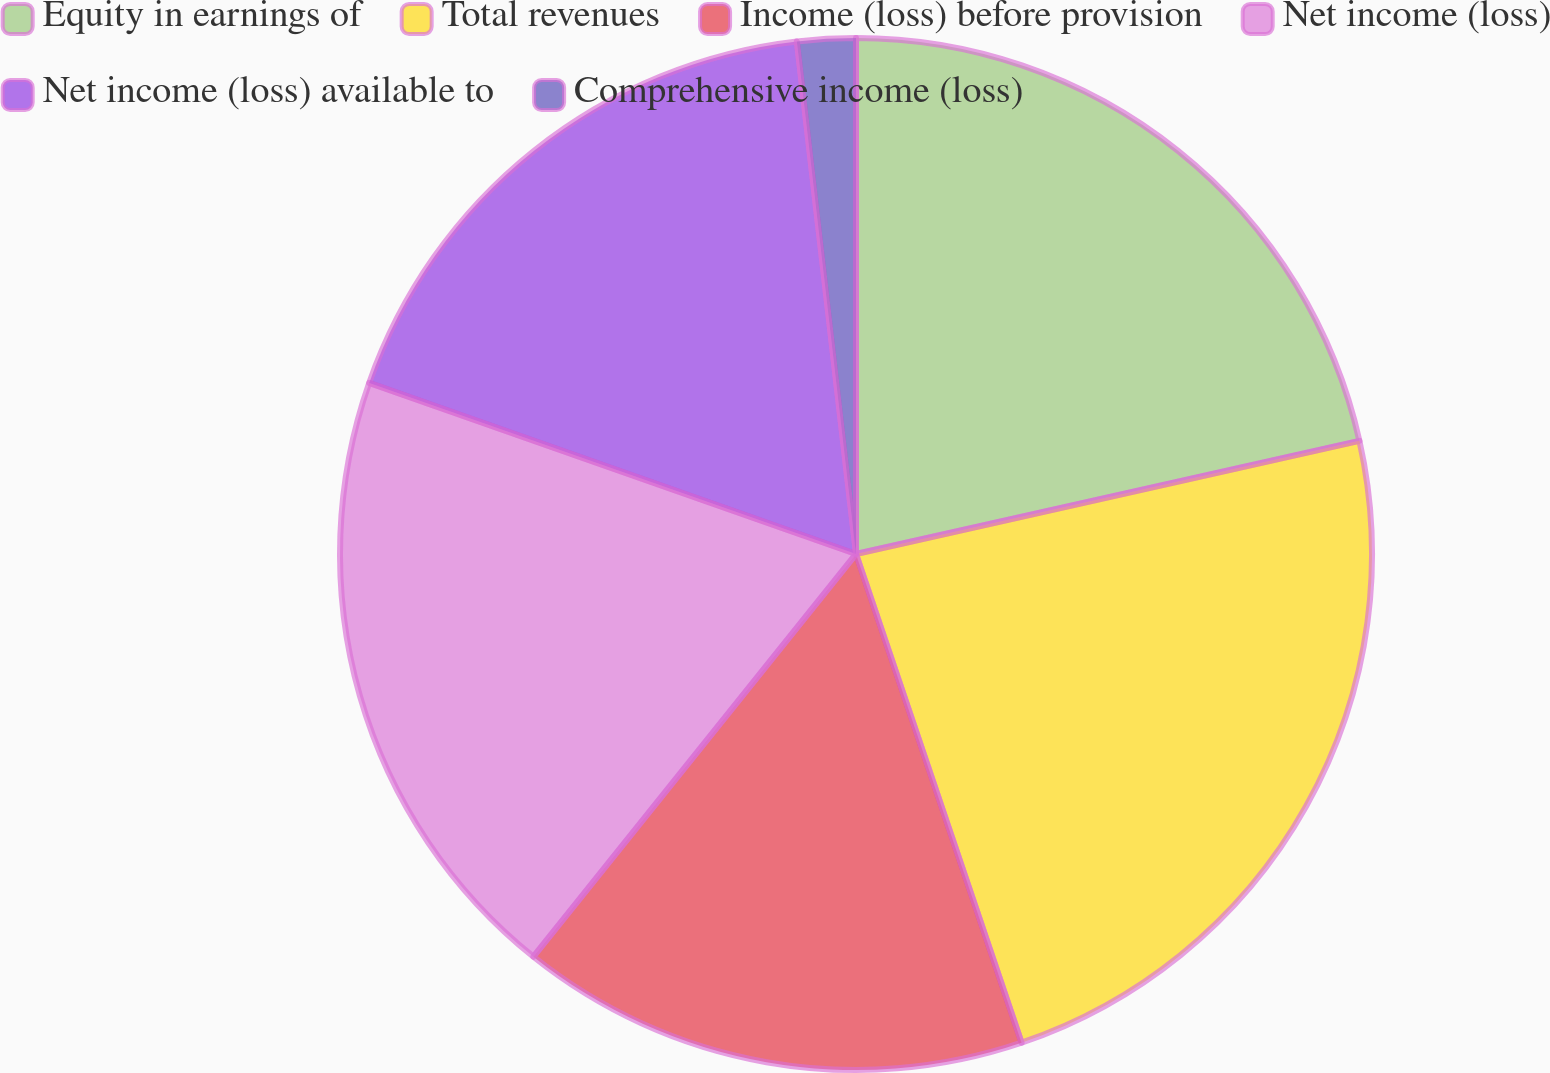Convert chart to OTSL. <chart><loc_0><loc_0><loc_500><loc_500><pie_chart><fcel>Equity in earnings of<fcel>Total revenues<fcel>Income (loss) before provision<fcel>Net income (loss)<fcel>Net income (loss) available to<fcel>Comprehensive income (loss)<nl><fcel>21.48%<fcel>23.32%<fcel>15.95%<fcel>19.63%<fcel>17.79%<fcel>1.83%<nl></chart> 